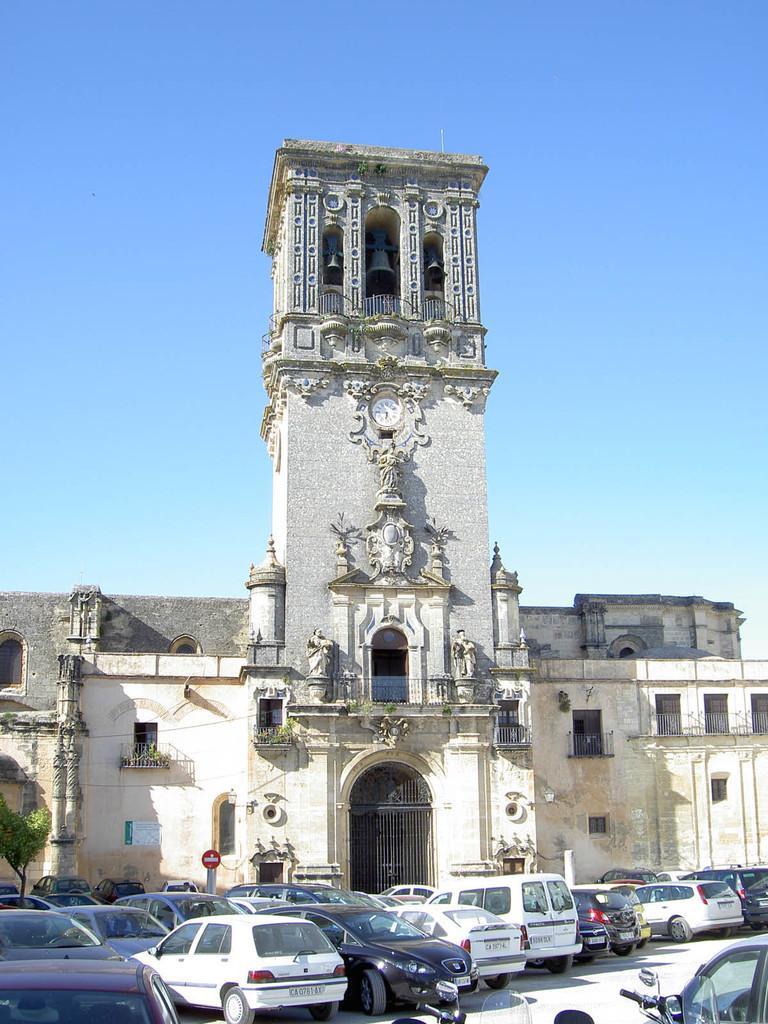Can you describe this image briefly? In this picture we can see vehicles on the ground, building with windows, plants, tree, statues, clock, bells, signboard, poster, grills and in the background we can see the sky. 